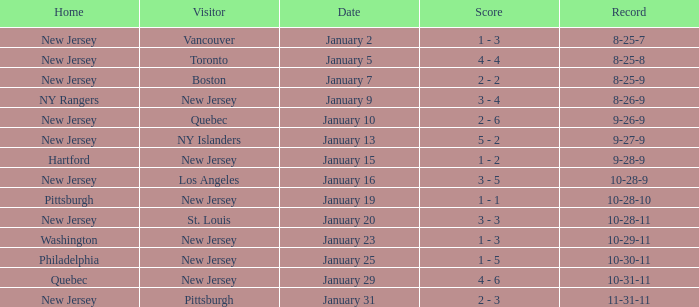What was the date that ended in a record of 8-25-7? January 2. 